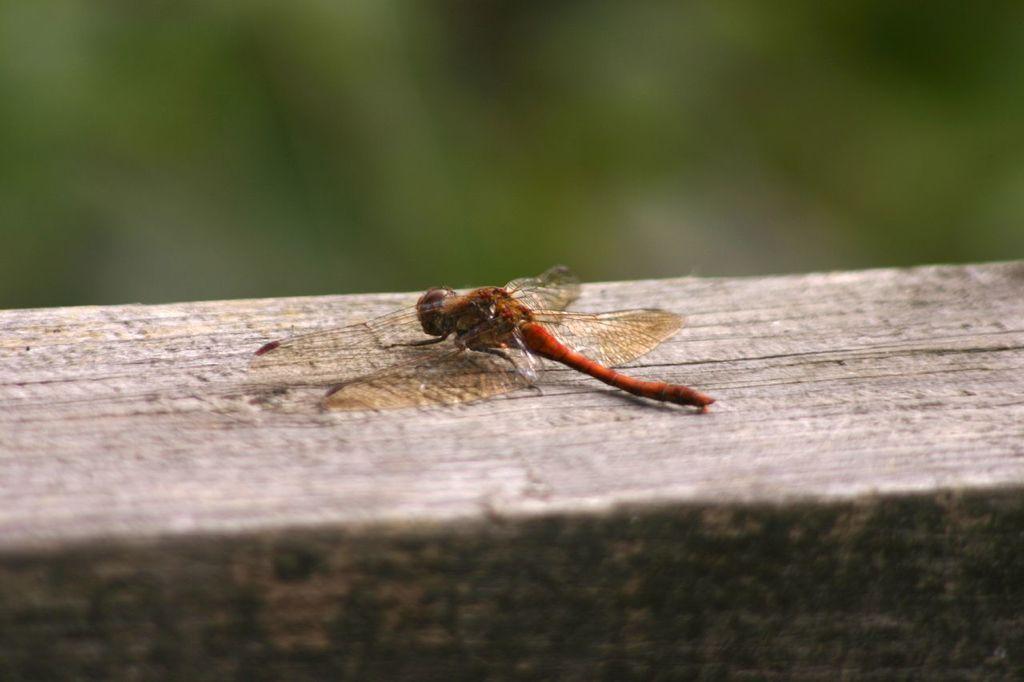Describe this image in one or two sentences. In this image there is a dragonfly on a wooden surface, in the background it is blurred. 